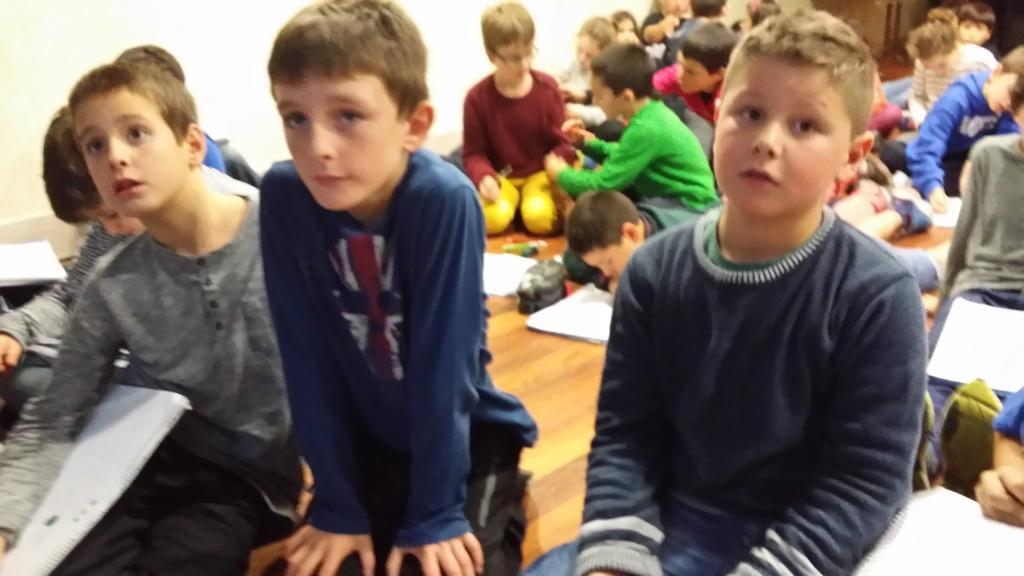How would you summarize this image in a sentence or two? In this picture there are group of people sitting. At the back there is a wall. At the bottom there are books and there are objects on the floor. 